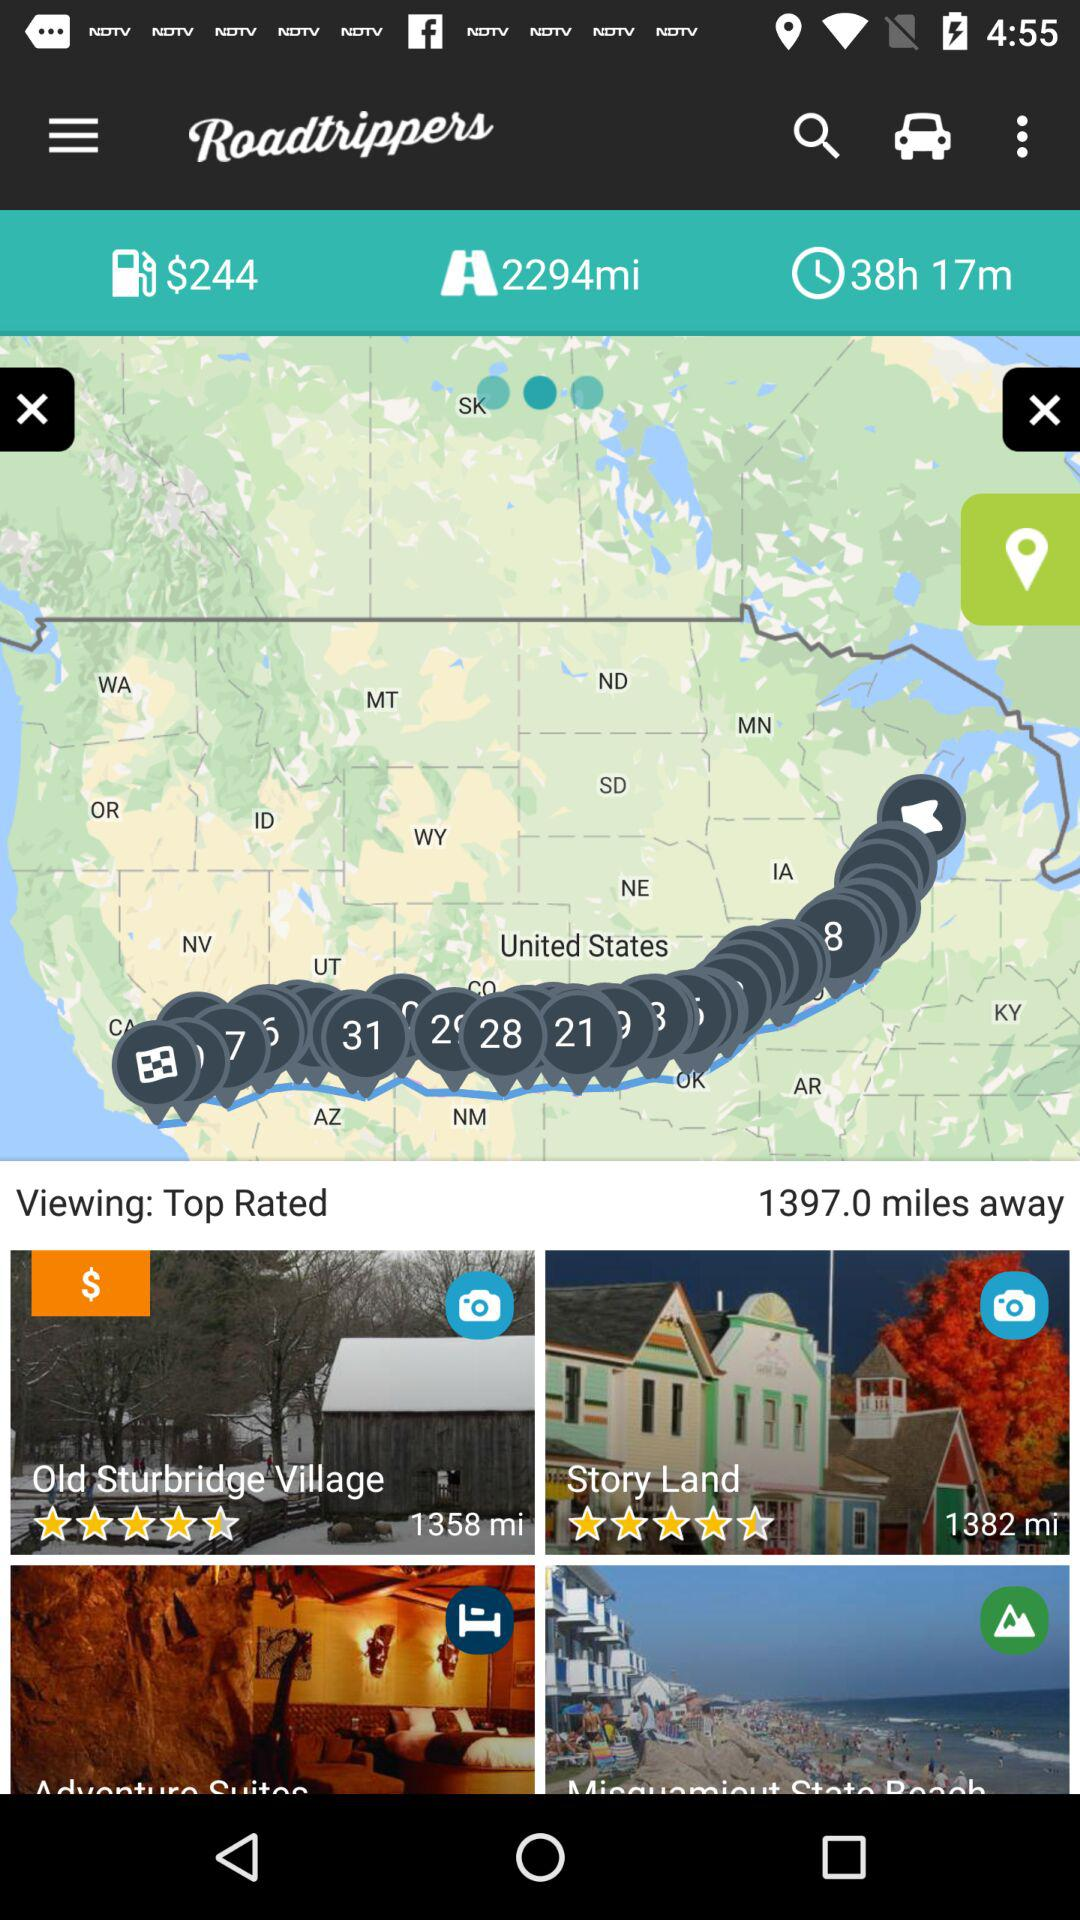What place is at a distance of 1358 miles? The place is "Old Sturbridge Village". 